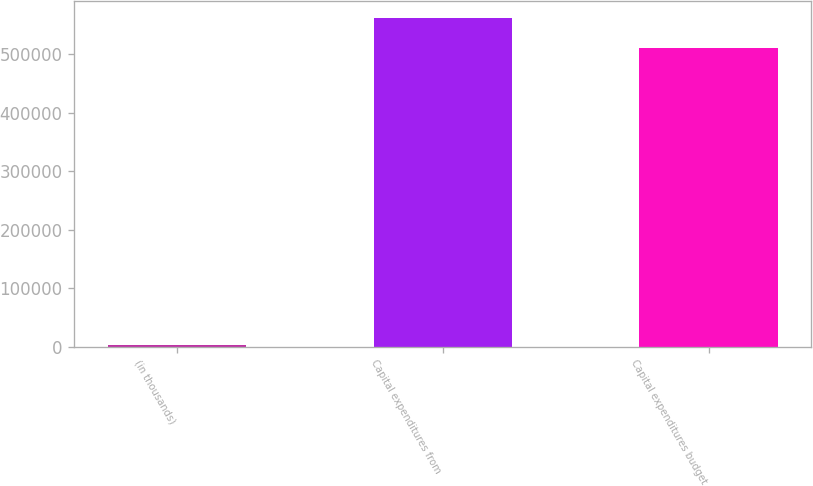<chart> <loc_0><loc_0><loc_500><loc_500><bar_chart><fcel>(in thousands)<fcel>Capital expenditures from<fcel>Capital expenditures budget<nl><fcel>2003<fcel>562538<fcel>510000<nl></chart> 